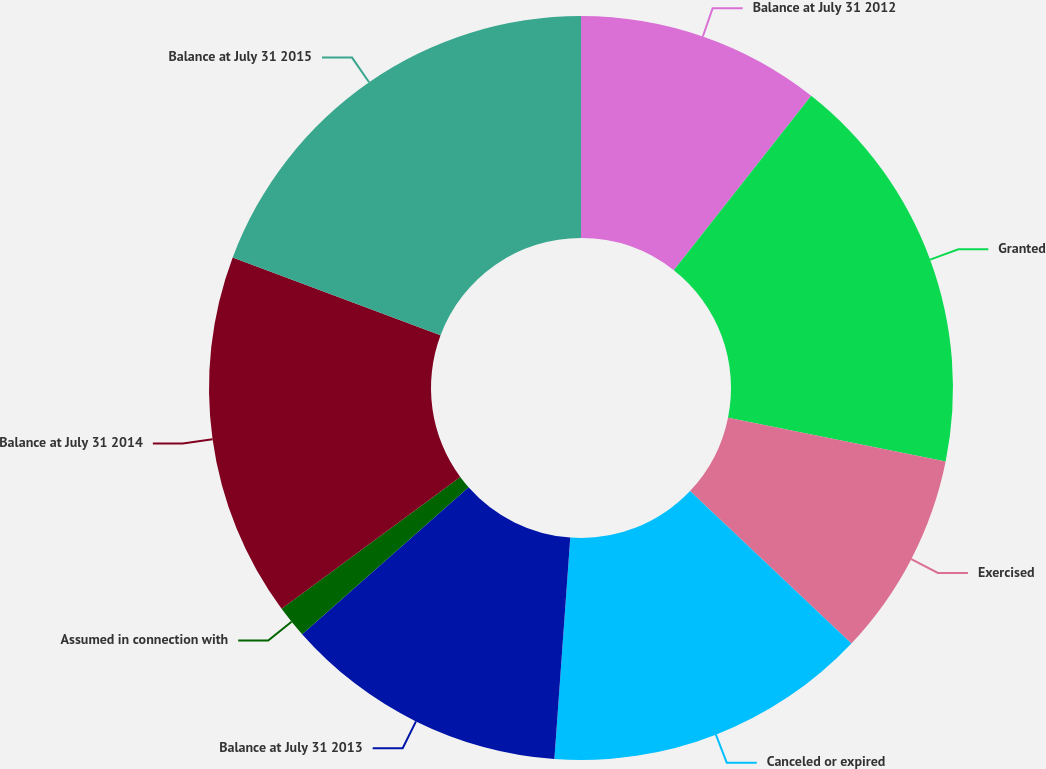<chart> <loc_0><loc_0><loc_500><loc_500><pie_chart><fcel>Balance at July 31 2012<fcel>Granted<fcel>Exercised<fcel>Canceled or expired<fcel>Balance at July 31 2013<fcel>Assumed in connection with<fcel>Balance at July 31 2014<fcel>Balance at July 31 2015<nl><fcel>10.62%<fcel>17.55%<fcel>8.88%<fcel>14.09%<fcel>12.35%<fcel>1.4%<fcel>15.82%<fcel>19.29%<nl></chart> 